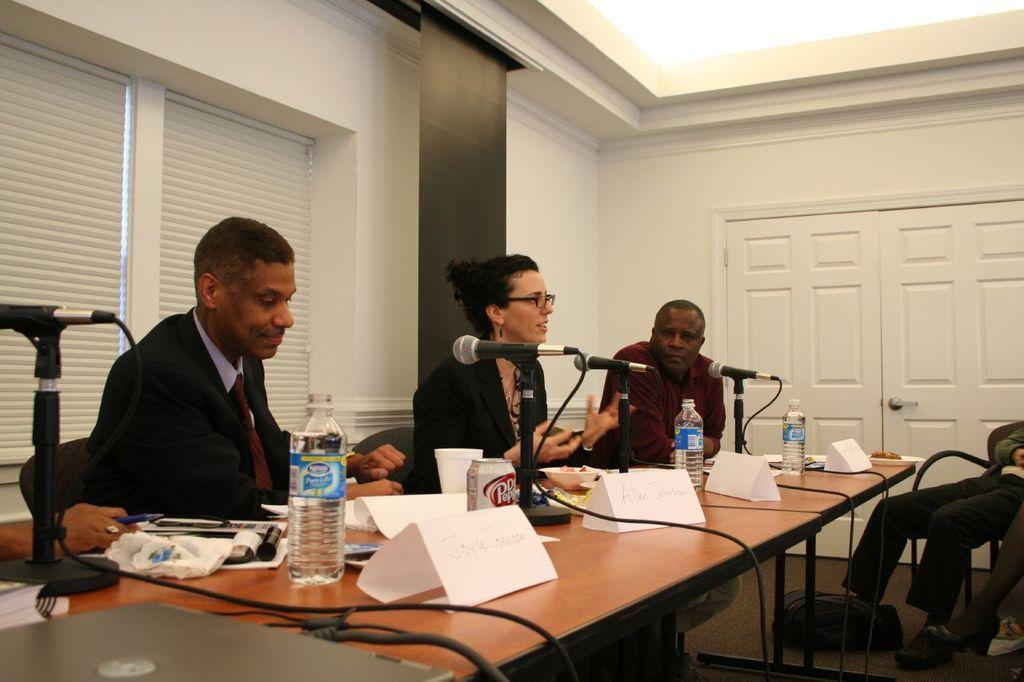What are the people in the image doing? The people in the image are sitting on the table. What objects are in front of the people? Mics are placed in front of the people. What can be seen on the table besides the people and mics? Water bottles are present on the table. What additional information is visible on the table? Labels are visible on the table. What type of war is being discussed by the people sitting on the table? There is no indication of a war or any discussion about war in the image. 